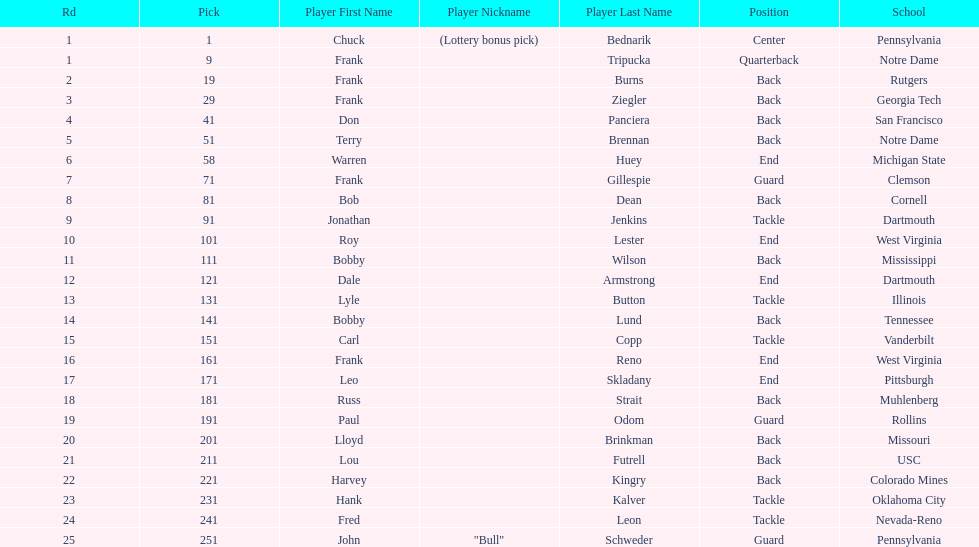Who was picked after frank burns? Frank Ziegler. 